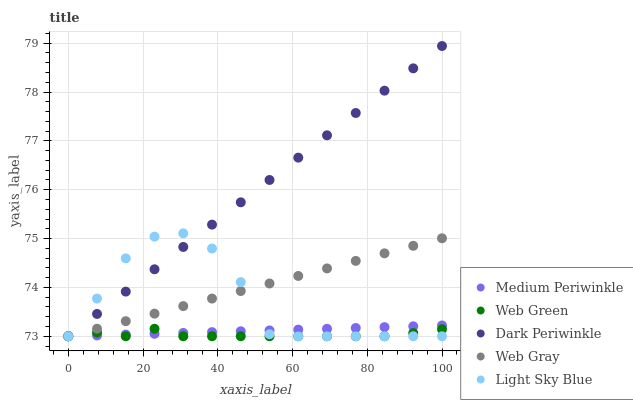Does Web Green have the minimum area under the curve?
Answer yes or no. Yes. Does Dark Periwinkle have the maximum area under the curve?
Answer yes or no. Yes. Does Medium Periwinkle have the minimum area under the curve?
Answer yes or no. No. Does Medium Periwinkle have the maximum area under the curve?
Answer yes or no. No. Is Medium Periwinkle the smoothest?
Answer yes or no. Yes. Is Light Sky Blue the roughest?
Answer yes or no. Yes. Is Dark Periwinkle the smoothest?
Answer yes or no. No. Is Dark Periwinkle the roughest?
Answer yes or no. No. Does Web Gray have the lowest value?
Answer yes or no. Yes. Does Dark Periwinkle have the highest value?
Answer yes or no. Yes. Does Medium Periwinkle have the highest value?
Answer yes or no. No. Does Dark Periwinkle intersect Medium Periwinkle?
Answer yes or no. Yes. Is Dark Periwinkle less than Medium Periwinkle?
Answer yes or no. No. Is Dark Periwinkle greater than Medium Periwinkle?
Answer yes or no. No. 